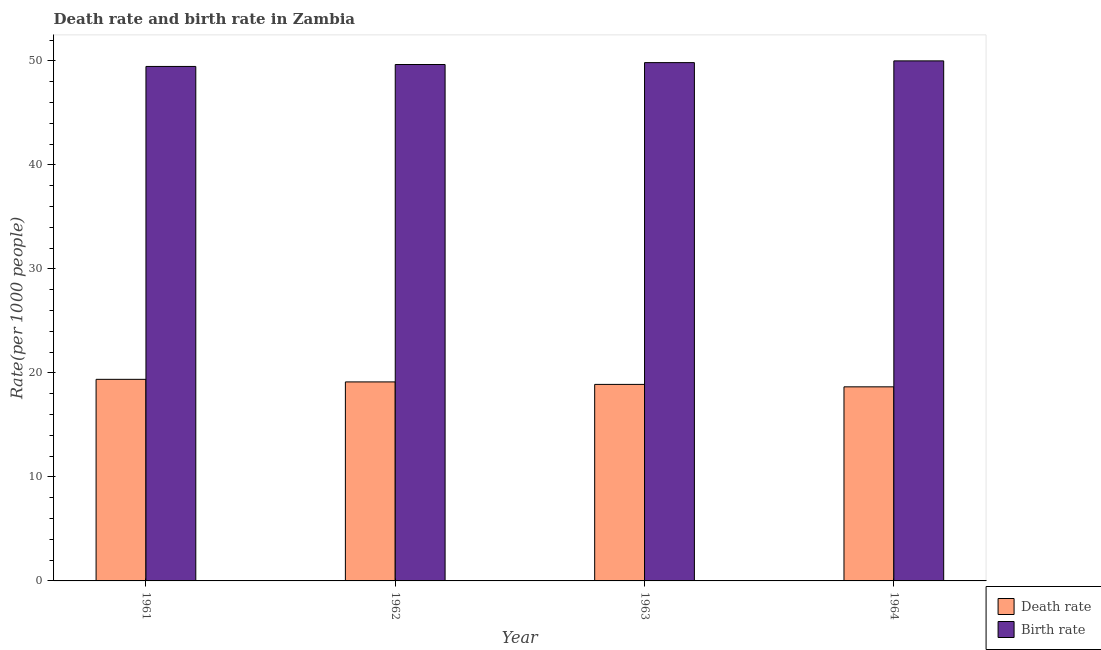How many different coloured bars are there?
Keep it short and to the point. 2. How many groups of bars are there?
Ensure brevity in your answer.  4. Are the number of bars per tick equal to the number of legend labels?
Ensure brevity in your answer.  Yes. How many bars are there on the 4th tick from the left?
Your response must be concise. 2. In how many cases, is the number of bars for a given year not equal to the number of legend labels?
Keep it short and to the point. 0. What is the birth rate in 1964?
Provide a succinct answer. 50. Across all years, what is the maximum death rate?
Ensure brevity in your answer.  19.38. Across all years, what is the minimum birth rate?
Keep it short and to the point. 49.46. In which year was the death rate maximum?
Give a very brief answer. 1961. In which year was the death rate minimum?
Keep it short and to the point. 1964. What is the total birth rate in the graph?
Your answer should be very brief. 198.94. What is the difference between the death rate in 1962 and that in 1964?
Your answer should be very brief. 0.47. What is the difference between the birth rate in 1962 and the death rate in 1964?
Your answer should be very brief. -0.35. What is the average birth rate per year?
Provide a succinct answer. 49.73. In the year 1963, what is the difference between the birth rate and death rate?
Offer a very short reply. 0. What is the ratio of the birth rate in 1963 to that in 1964?
Your response must be concise. 1. Is the death rate in 1961 less than that in 1962?
Provide a short and direct response. No. Is the difference between the death rate in 1962 and 1963 greater than the difference between the birth rate in 1962 and 1963?
Give a very brief answer. No. What is the difference between the highest and the second highest death rate?
Make the answer very short. 0.25. What is the difference between the highest and the lowest death rate?
Offer a very short reply. 0.72. What does the 1st bar from the left in 1964 represents?
Your answer should be very brief. Death rate. What does the 1st bar from the right in 1963 represents?
Provide a short and direct response. Birth rate. How many bars are there?
Offer a very short reply. 8. How many years are there in the graph?
Give a very brief answer. 4. What is the difference between two consecutive major ticks on the Y-axis?
Your answer should be very brief. 10. How are the legend labels stacked?
Provide a short and direct response. Vertical. What is the title of the graph?
Keep it short and to the point. Death rate and birth rate in Zambia. What is the label or title of the Y-axis?
Your response must be concise. Rate(per 1000 people). What is the Rate(per 1000 people) of Death rate in 1961?
Provide a succinct answer. 19.38. What is the Rate(per 1000 people) in Birth rate in 1961?
Your answer should be very brief. 49.46. What is the Rate(per 1000 people) in Death rate in 1962?
Provide a short and direct response. 19.13. What is the Rate(per 1000 people) of Birth rate in 1962?
Keep it short and to the point. 49.65. What is the Rate(per 1000 people) in Death rate in 1963?
Your response must be concise. 18.89. What is the Rate(per 1000 people) of Birth rate in 1963?
Give a very brief answer. 49.83. What is the Rate(per 1000 people) in Death rate in 1964?
Provide a succinct answer. 18.66. What is the Rate(per 1000 people) in Birth rate in 1964?
Your answer should be very brief. 50. Across all years, what is the maximum Rate(per 1000 people) of Death rate?
Give a very brief answer. 19.38. Across all years, what is the maximum Rate(per 1000 people) of Birth rate?
Offer a terse response. 50. Across all years, what is the minimum Rate(per 1000 people) in Death rate?
Offer a terse response. 18.66. Across all years, what is the minimum Rate(per 1000 people) in Birth rate?
Provide a short and direct response. 49.46. What is the total Rate(per 1000 people) in Death rate in the graph?
Make the answer very short. 76.07. What is the total Rate(per 1000 people) in Birth rate in the graph?
Make the answer very short. 198.94. What is the difference between the Rate(per 1000 people) of Death rate in 1961 and that in 1962?
Your answer should be compact. 0.25. What is the difference between the Rate(per 1000 people) of Birth rate in 1961 and that in 1962?
Keep it short and to the point. -0.19. What is the difference between the Rate(per 1000 people) of Death rate in 1961 and that in 1963?
Offer a terse response. 0.49. What is the difference between the Rate(per 1000 people) in Birth rate in 1961 and that in 1963?
Offer a terse response. -0.37. What is the difference between the Rate(per 1000 people) of Death rate in 1961 and that in 1964?
Provide a succinct answer. 0.72. What is the difference between the Rate(per 1000 people) of Birth rate in 1961 and that in 1964?
Offer a terse response. -0.54. What is the difference between the Rate(per 1000 people) of Death rate in 1962 and that in 1963?
Make the answer very short. 0.24. What is the difference between the Rate(per 1000 people) in Birth rate in 1962 and that in 1963?
Offer a very short reply. -0.18. What is the difference between the Rate(per 1000 people) of Death rate in 1962 and that in 1964?
Offer a very short reply. 0.47. What is the difference between the Rate(per 1000 people) in Birth rate in 1962 and that in 1964?
Give a very brief answer. -0.35. What is the difference between the Rate(per 1000 people) in Death rate in 1963 and that in 1964?
Your response must be concise. 0.23. What is the difference between the Rate(per 1000 people) in Birth rate in 1963 and that in 1964?
Your answer should be compact. -0.17. What is the difference between the Rate(per 1000 people) of Death rate in 1961 and the Rate(per 1000 people) of Birth rate in 1962?
Offer a terse response. -30.27. What is the difference between the Rate(per 1000 people) of Death rate in 1961 and the Rate(per 1000 people) of Birth rate in 1963?
Provide a succinct answer. -30.45. What is the difference between the Rate(per 1000 people) of Death rate in 1961 and the Rate(per 1000 people) of Birth rate in 1964?
Provide a succinct answer. -30.62. What is the difference between the Rate(per 1000 people) in Death rate in 1962 and the Rate(per 1000 people) in Birth rate in 1963?
Keep it short and to the point. -30.7. What is the difference between the Rate(per 1000 people) in Death rate in 1962 and the Rate(per 1000 people) in Birth rate in 1964?
Provide a succinct answer. -30.86. What is the difference between the Rate(per 1000 people) in Death rate in 1963 and the Rate(per 1000 people) in Birth rate in 1964?
Provide a succinct answer. -31.1. What is the average Rate(per 1000 people) in Death rate per year?
Your answer should be very brief. 19.02. What is the average Rate(per 1000 people) in Birth rate per year?
Offer a terse response. 49.73. In the year 1961, what is the difference between the Rate(per 1000 people) of Death rate and Rate(per 1000 people) of Birth rate?
Your response must be concise. -30.08. In the year 1962, what is the difference between the Rate(per 1000 people) of Death rate and Rate(per 1000 people) of Birth rate?
Provide a succinct answer. -30.52. In the year 1963, what is the difference between the Rate(per 1000 people) in Death rate and Rate(per 1000 people) in Birth rate?
Your answer should be compact. -30.94. In the year 1964, what is the difference between the Rate(per 1000 people) in Death rate and Rate(per 1000 people) in Birth rate?
Keep it short and to the point. -31.34. What is the ratio of the Rate(per 1000 people) in Birth rate in 1961 to that in 1962?
Your answer should be compact. 1. What is the ratio of the Rate(per 1000 people) of Death rate in 1961 to that in 1963?
Your answer should be compact. 1.03. What is the ratio of the Rate(per 1000 people) of Birth rate in 1961 to that in 1963?
Your response must be concise. 0.99. What is the ratio of the Rate(per 1000 people) of Death rate in 1961 to that in 1964?
Your response must be concise. 1.04. What is the ratio of the Rate(per 1000 people) of Birth rate in 1961 to that in 1964?
Provide a short and direct response. 0.99. What is the ratio of the Rate(per 1000 people) in Death rate in 1962 to that in 1963?
Your answer should be very brief. 1.01. What is the ratio of the Rate(per 1000 people) of Death rate in 1962 to that in 1964?
Provide a short and direct response. 1.03. What is the ratio of the Rate(per 1000 people) in Death rate in 1963 to that in 1964?
Give a very brief answer. 1.01. What is the ratio of the Rate(per 1000 people) in Birth rate in 1963 to that in 1964?
Your response must be concise. 1. What is the difference between the highest and the second highest Rate(per 1000 people) in Death rate?
Provide a short and direct response. 0.25. What is the difference between the highest and the second highest Rate(per 1000 people) in Birth rate?
Your response must be concise. 0.17. What is the difference between the highest and the lowest Rate(per 1000 people) of Death rate?
Your answer should be very brief. 0.72. What is the difference between the highest and the lowest Rate(per 1000 people) in Birth rate?
Keep it short and to the point. 0.54. 